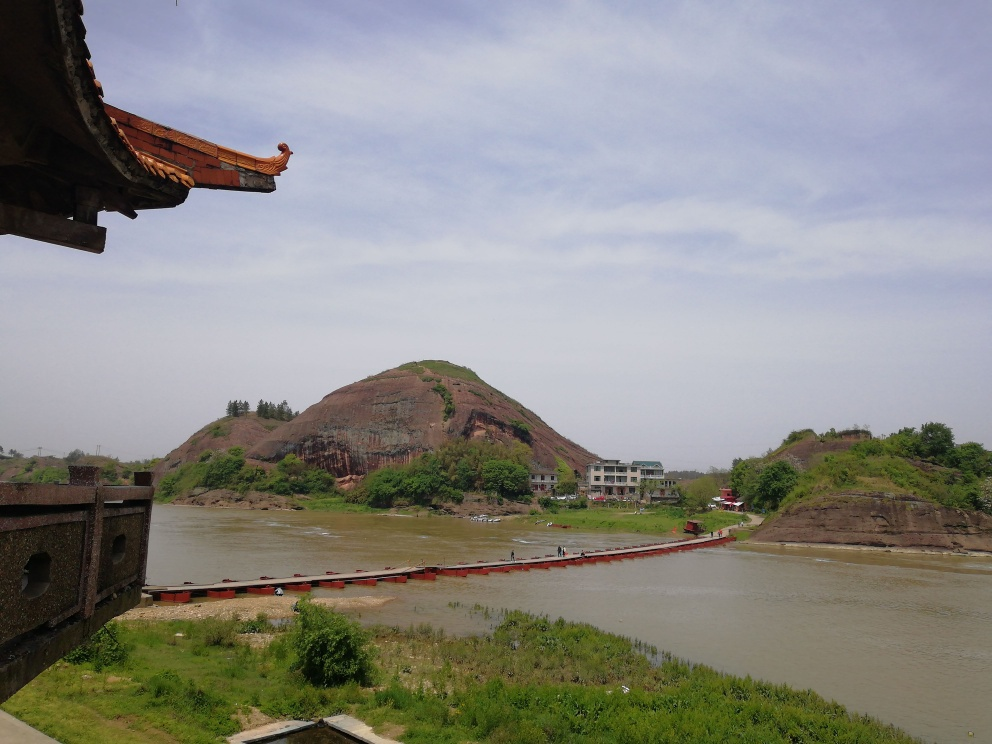Are there any specific flaws in this image?
A. Yes
B. No
Answer with the option's letter from the given choices directly.
 B. 